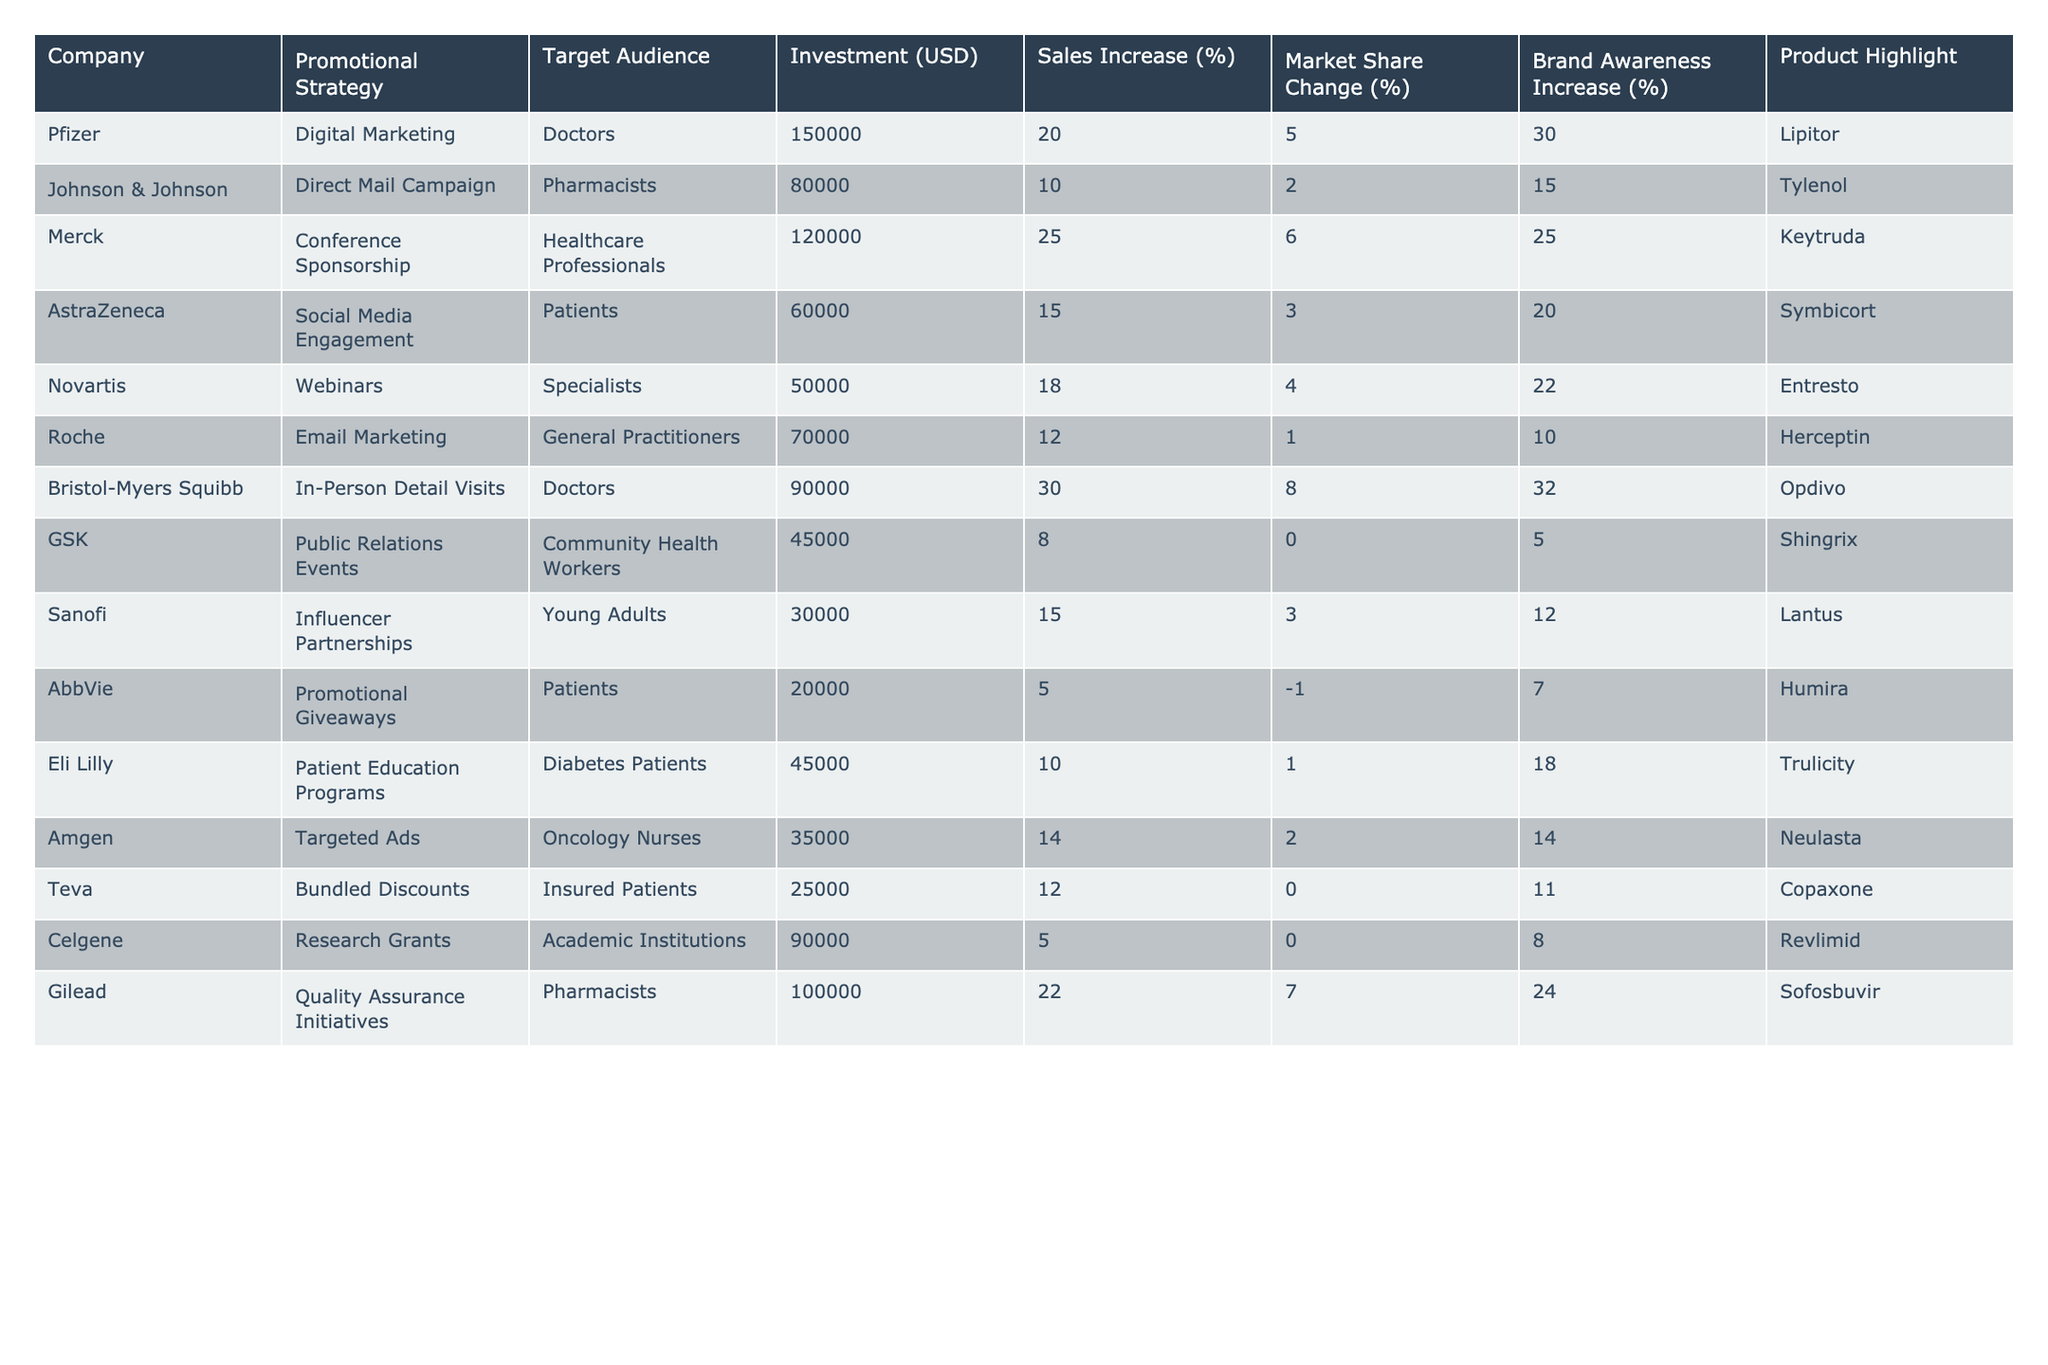What is the promotional strategy used by Gilead? By looking at the "Promotional Strategy" column in the table, Gilead's strategy is listed as "Quality Assurance Initiatives."
Answer: Quality Assurance Initiatives Which company had the highest sales increase percentage? The "Sales Increase (%)" column shows that Bristol-Myers Squibb had the highest value at 30%.
Answer: Bristol-Myers Squibb What is the average market share change across all companies? To find the average, sum the market share change percentages and then divide by the number of companies. The total is 43%, and there are 12 companies, so the average is 43/12 = approximately 3.58%.
Answer: 3.58% Did AstraZeneca's promotional efforts result in a market share increase? By checking the "Market Share Change (%)" column for AstraZeneca, we see it is 3%, which is a positive number, indicating an increase.
Answer: Yes Which company used the least investment in their promotional strategy? By looking at the "Investment (USD)" column, we can see that Sanofi invested 30,000 USD, which is the smallest amount.
Answer: Sanofi What is the combined sales increase percentage for companies using digital marketing? The only company listed with digital marketing is Pfizer, which had a sales increase of 20%. Therefore, the combined percentage is 20%.
Answer: 20% Is there a company that invested more than 100,000 USD in promotional strategies? The "Investment (USD)" column indicates that Gilead invested 100,000 USD, therefore it does not exceed that amount, and no company invested over 100,000 USD.
Answer: No What is the difference in brand awareness increase between Pfizer and Merck? Looking at the "Brand Awareness Increase (%)" column, Pfizer had a 30% increase and Merck had a 25% increase. The difference is 30% - 25% = 5%.
Answer: 5% Which promotional strategy yielded the highest brand awareness increase? By comparing the "Brand Awareness Increase (%)" values, the highest was from Bristol-Myers Squibb with 32%.
Answer: Bristol-Myers Squibb Can you identify any companies whose strategies did not result in a market share increase? By reviewing the "Market Share Change (%)" column, GSK and AbbVie both have market share change values of 0% or less, indicating no increase.
Answer: GSK and AbbVie 